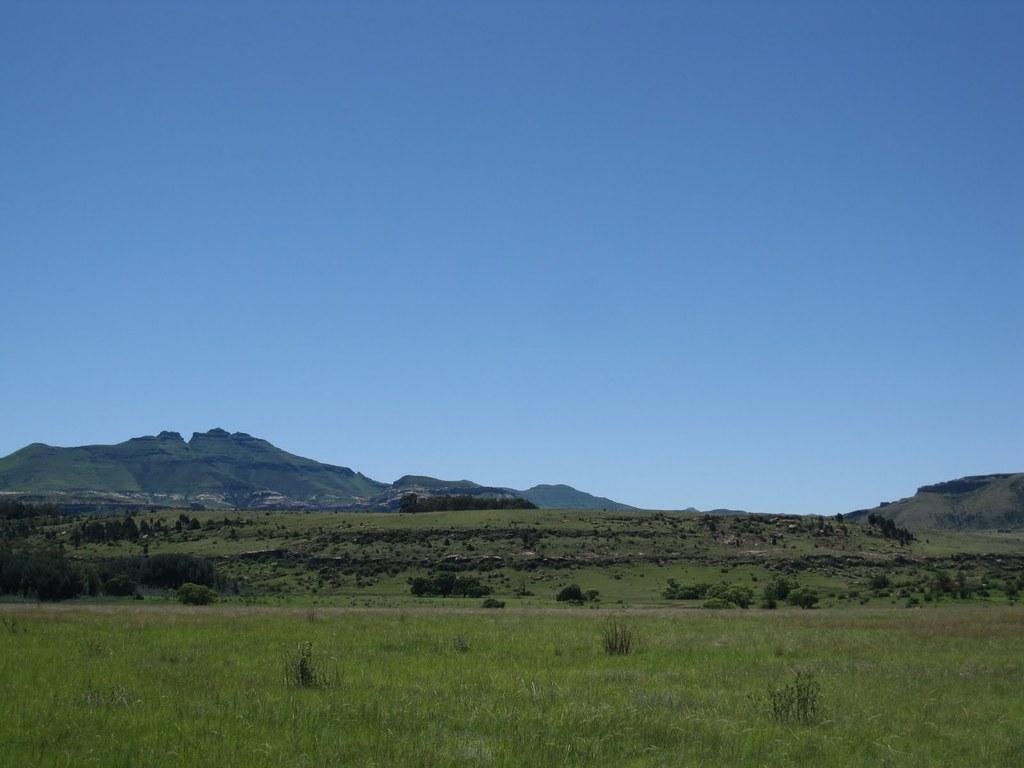What type of terrain is visible at the bottom of the image? There is grass at the bottom of the image. What type of natural features can be seen in the background of the image? There are mountains and trees in the background of the image. What is visible at the top of the image? The sky is visible at the top of the image. Can you tell me how many people are attending the church service in the image? There is no church or people attending a service present in the image. What type of offer is being made in the image? There is no offer being made in the image. 